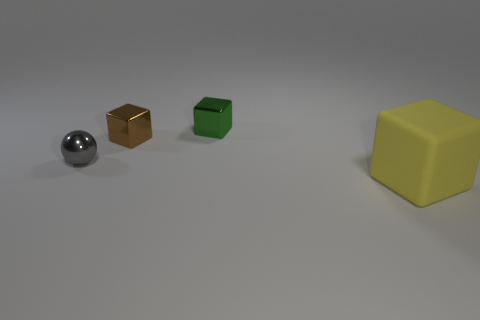There is a cube that is on the right side of the brown thing and left of the yellow matte object; what is it made of?
Give a very brief answer. Metal. Is there anything else that has the same size as the gray metal ball?
Offer a very short reply. Yes. Is the color of the matte thing the same as the tiny shiny ball?
Provide a short and direct response. No. How many other gray objects are the same shape as the big thing?
Provide a succinct answer. 0. What is the size of the green thing that is made of the same material as the ball?
Offer a terse response. Small. Is the yellow matte object the same size as the green cube?
Keep it short and to the point. No. Are any gray cubes visible?
Offer a terse response. No. How big is the metallic thing in front of the cube left of the block that is behind the brown metal cube?
Keep it short and to the point. Small. What number of cubes are made of the same material as the tiny brown object?
Make the answer very short. 1. How many green shiny objects have the same size as the metallic ball?
Ensure brevity in your answer.  1. 